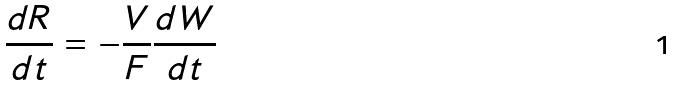Convert formula to latex. <formula><loc_0><loc_0><loc_500><loc_500>\frac { d R } { d t } = - \frac { V } { F } \frac { d W } { d t }</formula> 